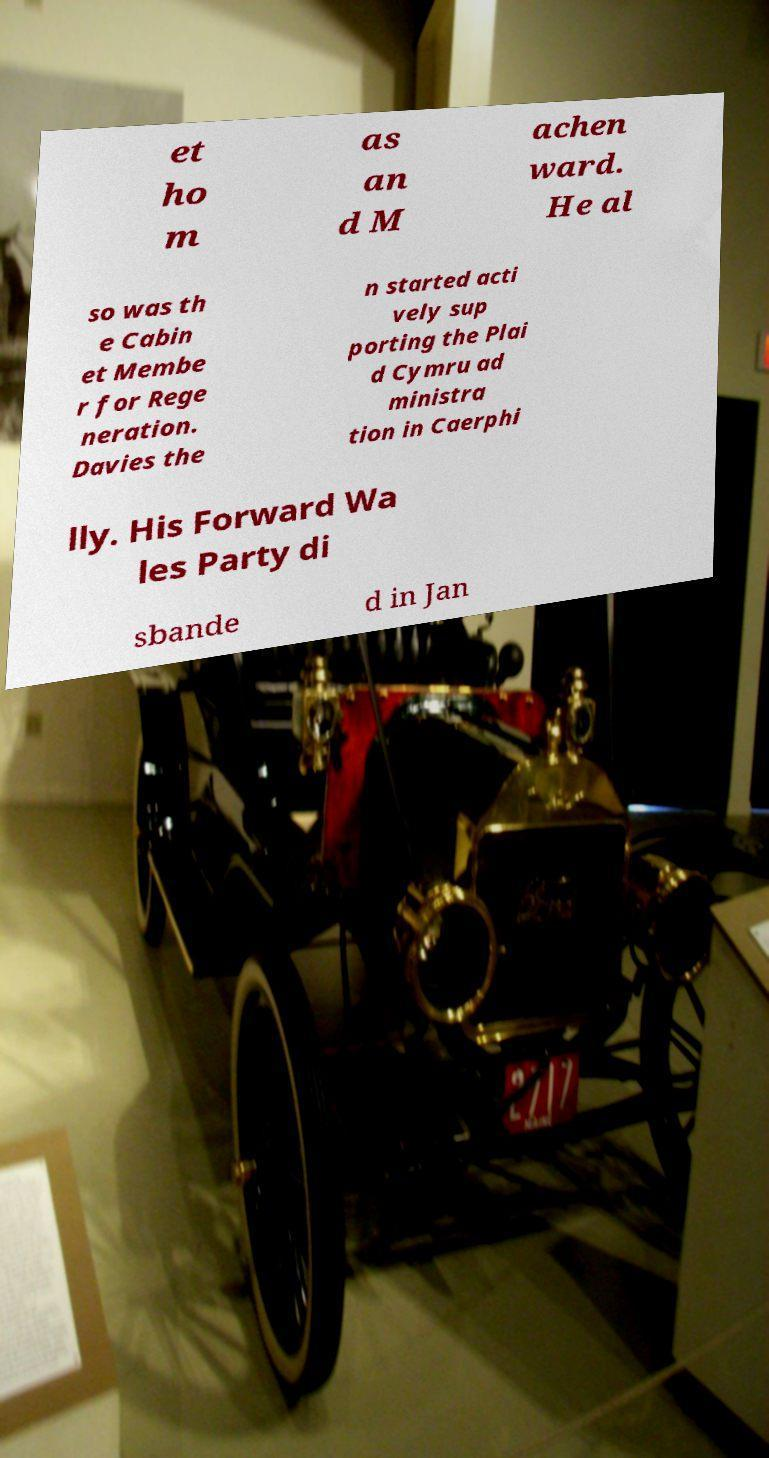Can you accurately transcribe the text from the provided image for me? et ho m as an d M achen ward. He al so was th e Cabin et Membe r for Rege neration. Davies the n started acti vely sup porting the Plai d Cymru ad ministra tion in Caerphi lly. His Forward Wa les Party di sbande d in Jan 